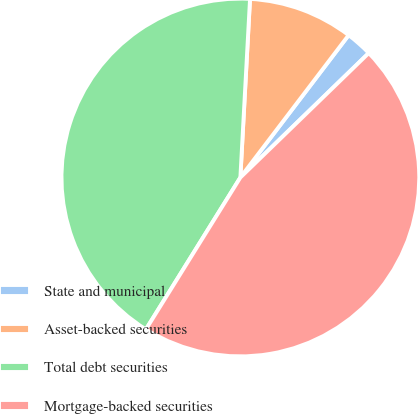Convert chart. <chart><loc_0><loc_0><loc_500><loc_500><pie_chart><fcel>State and municipal<fcel>Asset-backed securities<fcel>Total debt securities<fcel>Mortgage-backed securities<nl><fcel>2.4%<fcel>9.49%<fcel>42.01%<fcel>46.11%<nl></chart> 